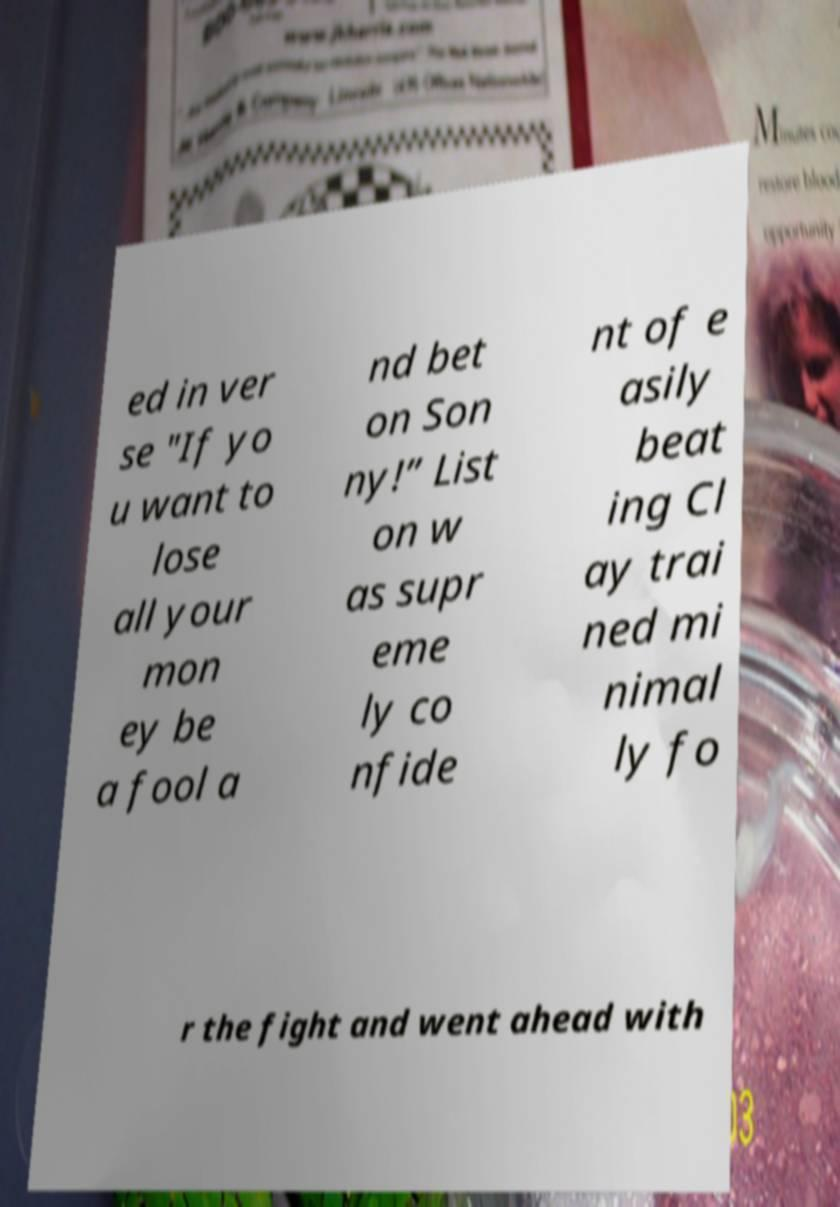Could you assist in decoding the text presented in this image and type it out clearly? ed in ver se "If yo u want to lose all your mon ey be a fool a nd bet on Son ny!” List on w as supr eme ly co nfide nt of e asily beat ing Cl ay trai ned mi nimal ly fo r the fight and went ahead with 